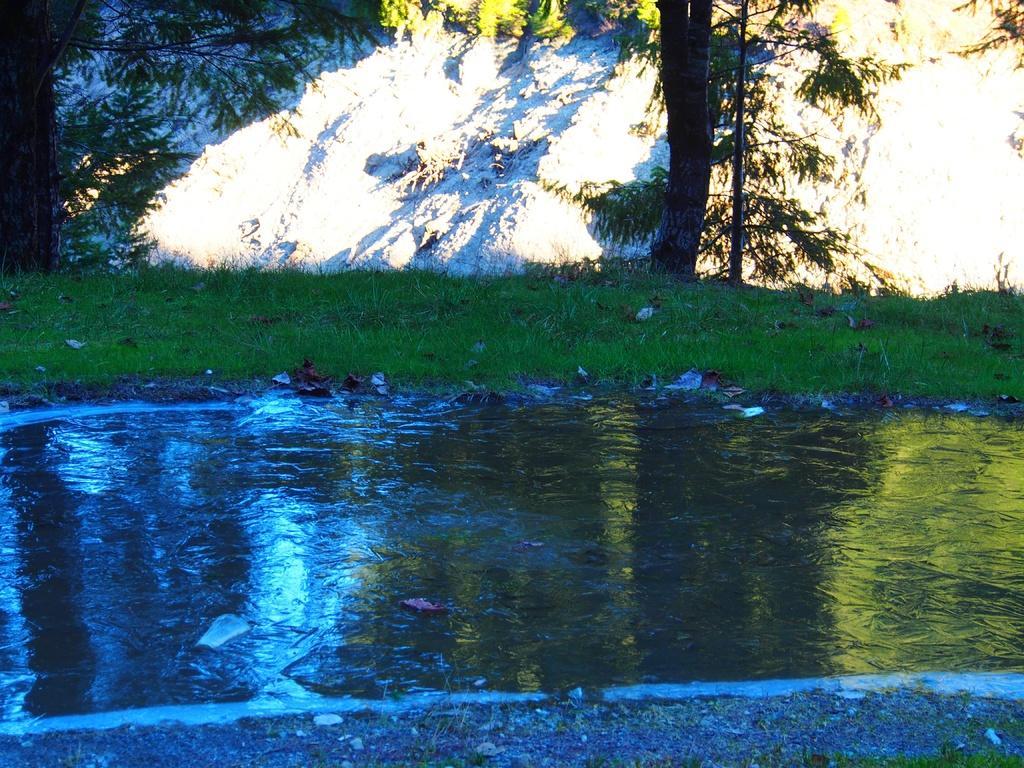How would you summarize this image in a sentence or two? In this picture we can see water, grass and trees. In the background of the image we can see rock. 